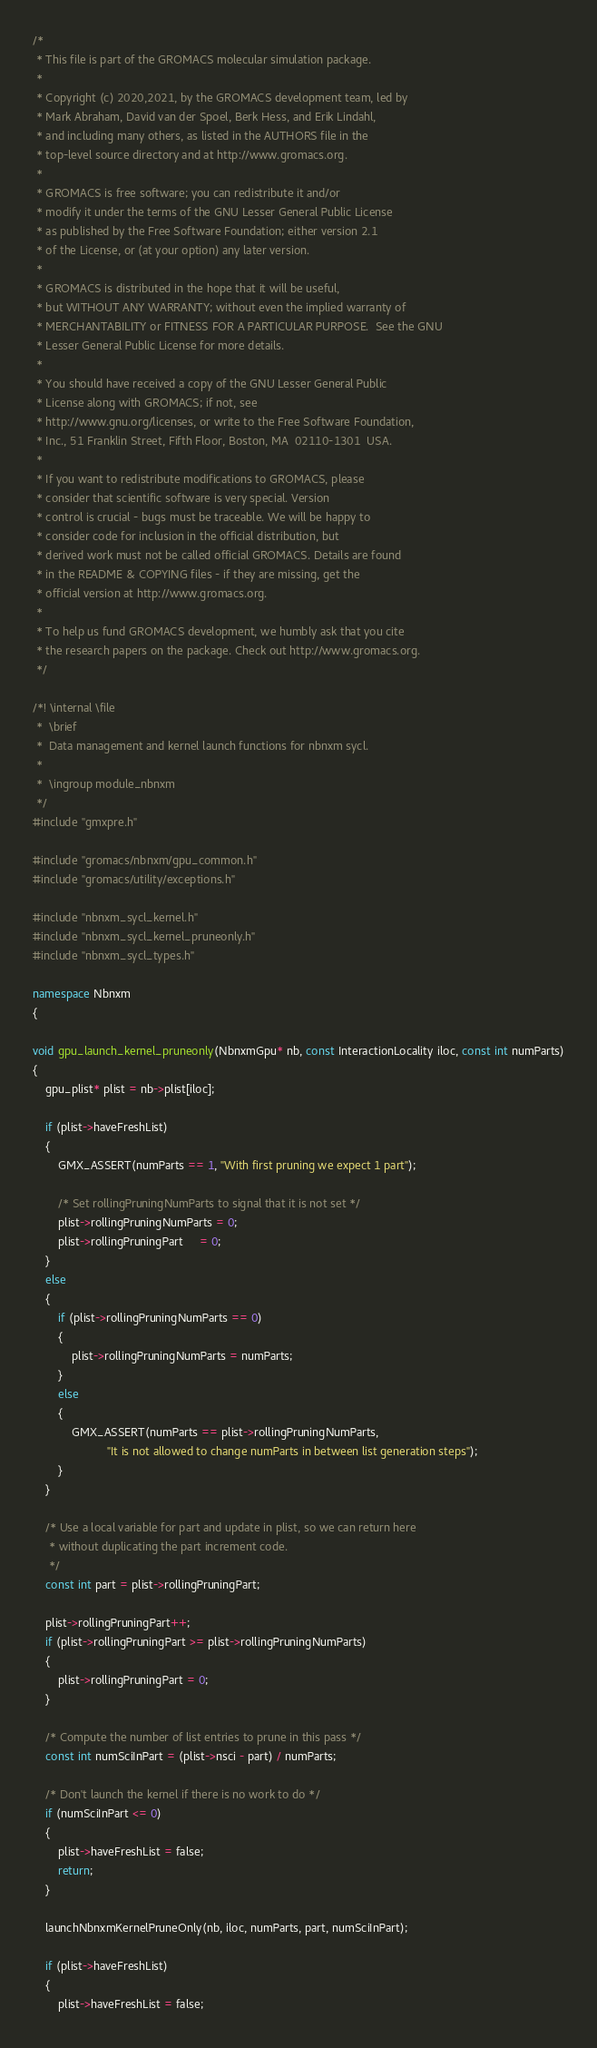Convert code to text. <code><loc_0><loc_0><loc_500><loc_500><_C++_>/*
 * This file is part of the GROMACS molecular simulation package.
 *
 * Copyright (c) 2020,2021, by the GROMACS development team, led by
 * Mark Abraham, David van der Spoel, Berk Hess, and Erik Lindahl,
 * and including many others, as listed in the AUTHORS file in the
 * top-level source directory and at http://www.gromacs.org.
 *
 * GROMACS is free software; you can redistribute it and/or
 * modify it under the terms of the GNU Lesser General Public License
 * as published by the Free Software Foundation; either version 2.1
 * of the License, or (at your option) any later version.
 *
 * GROMACS is distributed in the hope that it will be useful,
 * but WITHOUT ANY WARRANTY; without even the implied warranty of
 * MERCHANTABILITY or FITNESS FOR A PARTICULAR PURPOSE.  See the GNU
 * Lesser General Public License for more details.
 *
 * You should have received a copy of the GNU Lesser General Public
 * License along with GROMACS; if not, see
 * http://www.gnu.org/licenses, or write to the Free Software Foundation,
 * Inc., 51 Franklin Street, Fifth Floor, Boston, MA  02110-1301  USA.
 *
 * If you want to redistribute modifications to GROMACS, please
 * consider that scientific software is very special. Version
 * control is crucial - bugs must be traceable. We will be happy to
 * consider code for inclusion in the official distribution, but
 * derived work must not be called official GROMACS. Details are found
 * in the README & COPYING files - if they are missing, get the
 * official version at http://www.gromacs.org.
 *
 * To help us fund GROMACS development, we humbly ask that you cite
 * the research papers on the package. Check out http://www.gromacs.org.
 */

/*! \internal \file
 *  \brief
 *  Data management and kernel launch functions for nbnxm sycl.
 *
 *  \ingroup module_nbnxm
 */
#include "gmxpre.h"

#include "gromacs/nbnxm/gpu_common.h"
#include "gromacs/utility/exceptions.h"

#include "nbnxm_sycl_kernel.h"
#include "nbnxm_sycl_kernel_pruneonly.h"
#include "nbnxm_sycl_types.h"

namespace Nbnxm
{

void gpu_launch_kernel_pruneonly(NbnxmGpu* nb, const InteractionLocality iloc, const int numParts)
{
    gpu_plist* plist = nb->plist[iloc];

    if (plist->haveFreshList)
    {
        GMX_ASSERT(numParts == 1, "With first pruning we expect 1 part");

        /* Set rollingPruningNumParts to signal that it is not set */
        plist->rollingPruningNumParts = 0;
        plist->rollingPruningPart     = 0;
    }
    else
    {
        if (plist->rollingPruningNumParts == 0)
        {
            plist->rollingPruningNumParts = numParts;
        }
        else
        {
            GMX_ASSERT(numParts == plist->rollingPruningNumParts,
                       "It is not allowed to change numParts in between list generation steps");
        }
    }

    /* Use a local variable for part and update in plist, so we can return here
     * without duplicating the part increment code.
     */
    const int part = plist->rollingPruningPart;

    plist->rollingPruningPart++;
    if (plist->rollingPruningPart >= plist->rollingPruningNumParts)
    {
        plist->rollingPruningPart = 0;
    }

    /* Compute the number of list entries to prune in this pass */
    const int numSciInPart = (plist->nsci - part) / numParts;

    /* Don't launch the kernel if there is no work to do */
    if (numSciInPart <= 0)
    {
        plist->haveFreshList = false;
        return;
    }

    launchNbnxmKernelPruneOnly(nb, iloc, numParts, part, numSciInPart);

    if (plist->haveFreshList)
    {
        plist->haveFreshList = false;</code> 